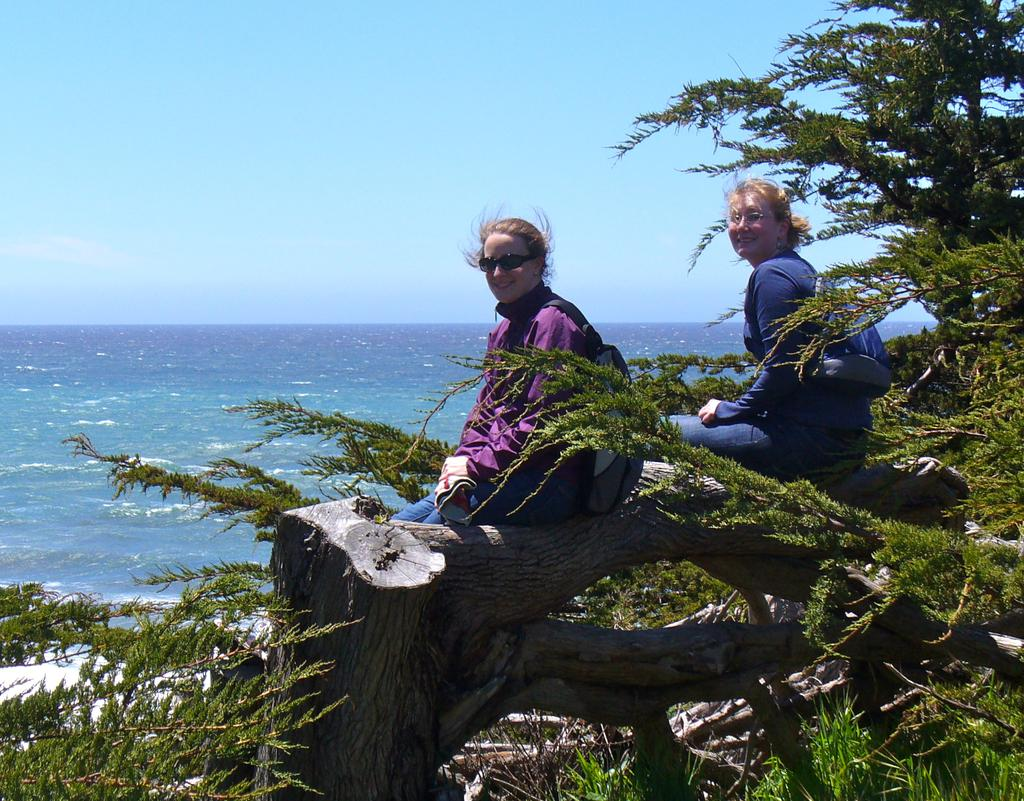How many people are sitting on the tree trunk in the image? There are two persons sitting on the tree trunk in the image. What is the facial expression of the persons in the image? The persons are smiling in the image. What type of natural environment is visible in the image? There are trees and water visible in the image, suggesting a natural setting. What can be seen in the background of the image? The sky is visible in the background of the image. What type of business is being conducted by the persons in the image? There is no indication of any business activity in the image; the persons are simply sitting on a tree trunk and smiling. What color is the skirt worn by the person on the left in the image? There is no person wearing a skirt in the image; both persons are wearing pants. 